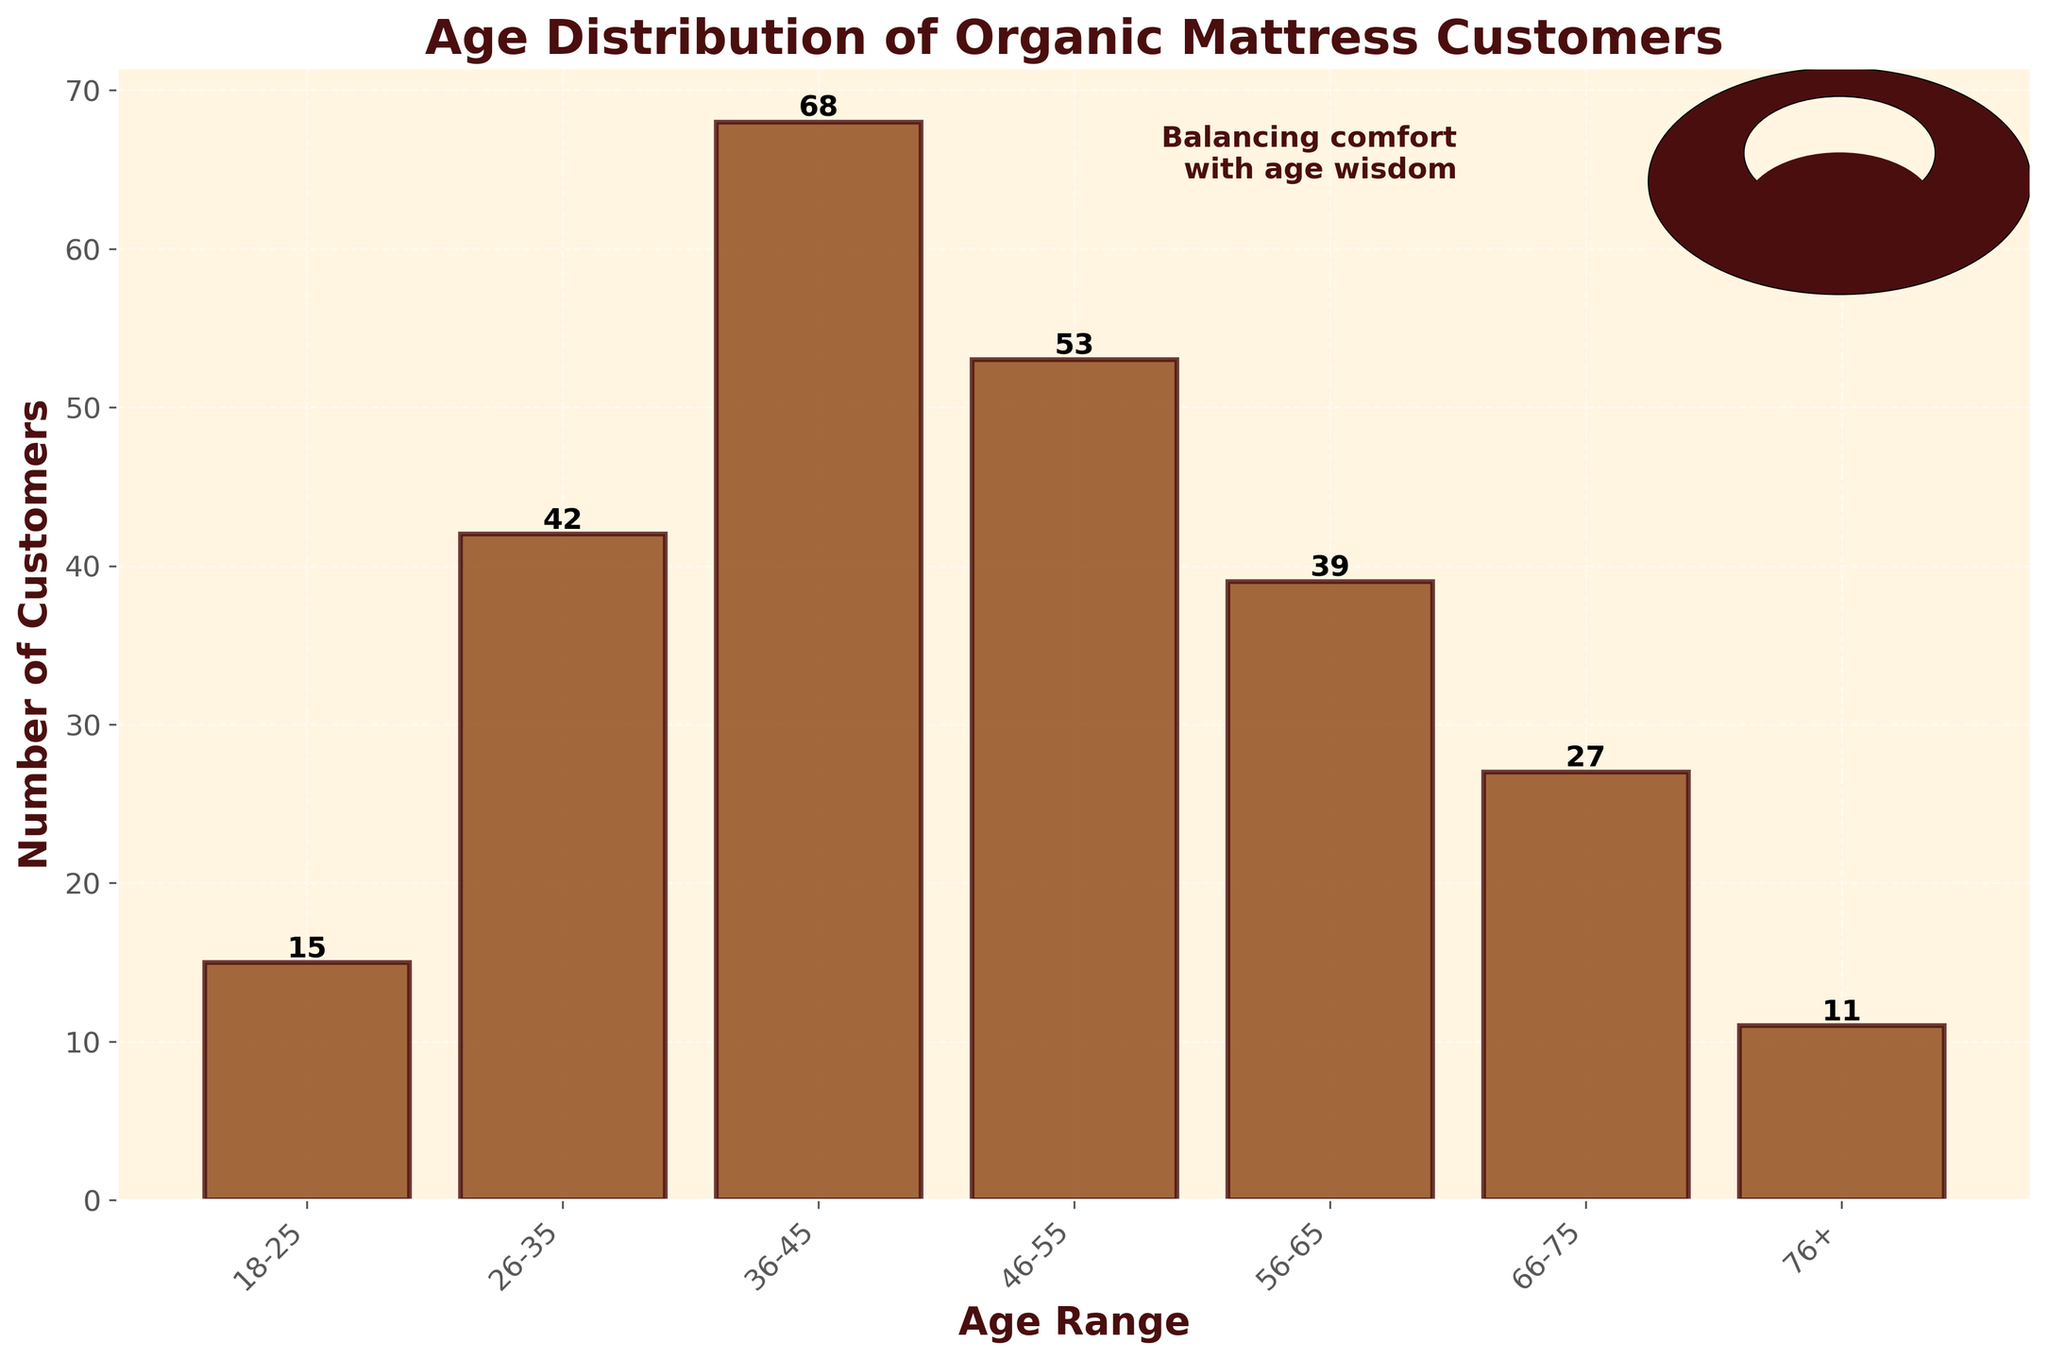What's the title of the histogram? The title is located at the top of the figure in bold, large font, which is typical for headings in charts.
Answer: Age Distribution of Organic Mattress Customers What is the color of the bars in the histogram? The bars of the histogram are colored in a specific shade, which is described in the figure.
Answer: Brown Which age group has the highest number of customers? By looking at the height of the bars, the tallest one represents the age group with the highest number of customers.
Answer: 36-45 How many customers are in the 66-75 age group? The number on top of the bar for each age group indicates the number of customers. Examine the bar labeled 66-75.
Answer: 27 What's the total number of customers across all age groups? Sum up the number of customers for each age group: 15 + 42 + 68 + 53 + 39 + 27 + 11.
Answer: 255 How many more customers are there in the age group 36-45 than in 56-65? Subtract the number of customers in the age group 56-65 from the number in the age group 36-45: 68 - 39.
Answer: 29 Which age groups have fewer than 20 customers? Identify the bars with a height indicating fewer than 20 customers, corresponding to the respective age ranges.
Answer: 18-25, 76+ What's the average number of customers per age group? Sum the total number of customers and divide by the number of age groups: 255 divided by 7.
Answer: 36.43 Compare the number of customers in the age groups 26-35 and 46-55. Which group has more? Look at the height of the bars for both age groups and compare them directly.
Answer: 46-55 What symbolic element is added to the figure for a touch of Eastern philosophy? Look at the additional designs in the figure and identify any non-data-related visual elements.
Answer: Yin-Yang symbol 